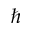Convert formula to latex. <formula><loc_0><loc_0><loc_500><loc_500>\hbar</formula> 